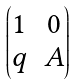<formula> <loc_0><loc_0><loc_500><loc_500>\begin{pmatrix} 1 & 0 \\ q & A \end{pmatrix}</formula> 